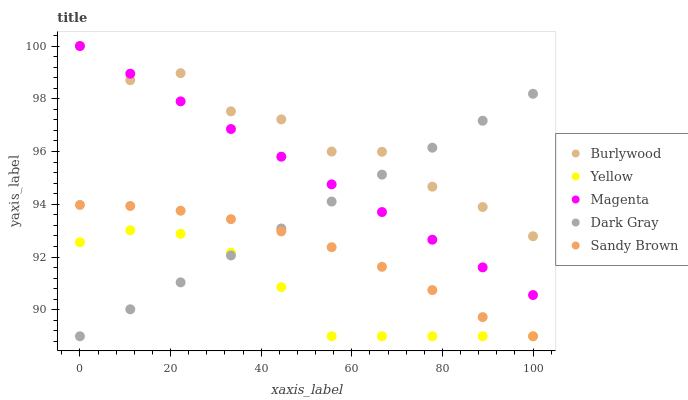Does Yellow have the minimum area under the curve?
Answer yes or no. Yes. Does Burlywood have the maximum area under the curve?
Answer yes or no. Yes. Does Dark Gray have the minimum area under the curve?
Answer yes or no. No. Does Dark Gray have the maximum area under the curve?
Answer yes or no. No. Is Dark Gray the smoothest?
Answer yes or no. Yes. Is Burlywood the roughest?
Answer yes or no. Yes. Is Magenta the smoothest?
Answer yes or no. No. Is Magenta the roughest?
Answer yes or no. No. Does Dark Gray have the lowest value?
Answer yes or no. Yes. Does Magenta have the lowest value?
Answer yes or no. No. Does Magenta have the highest value?
Answer yes or no. Yes. Does Dark Gray have the highest value?
Answer yes or no. No. Is Yellow less than Magenta?
Answer yes or no. Yes. Is Burlywood greater than Sandy Brown?
Answer yes or no. Yes. Does Sandy Brown intersect Yellow?
Answer yes or no. Yes. Is Sandy Brown less than Yellow?
Answer yes or no. No. Is Sandy Brown greater than Yellow?
Answer yes or no. No. Does Yellow intersect Magenta?
Answer yes or no. No. 